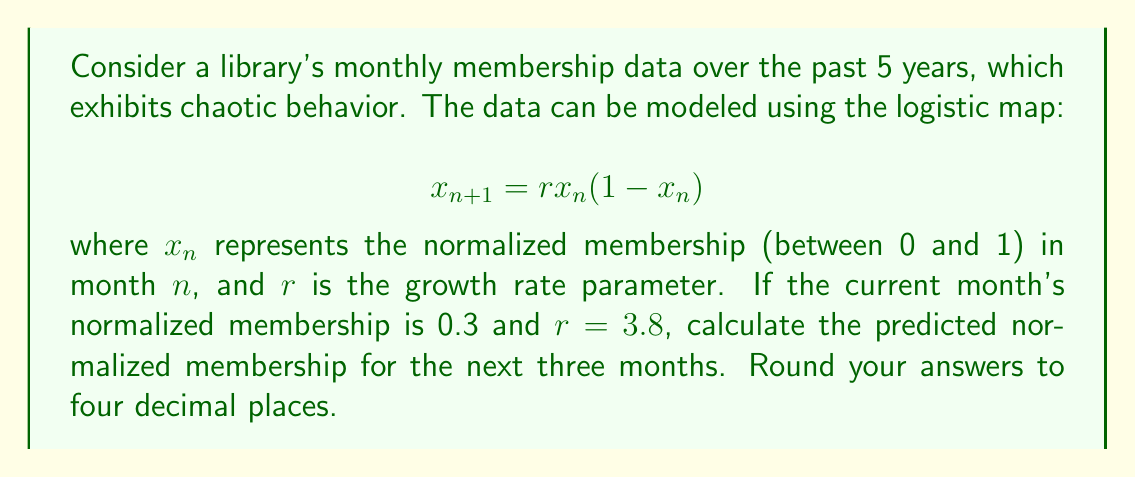Solve this math problem. To solve this problem, we'll use the logistic map equation iteratively for three months:

1. Given: $x_0 = 0.3$ and $r = 3.8$

2. For the first month ($n = 1$):
   $$x_1 = r \cdot x_0 \cdot (1-x_0)$$
   $$x_1 = 3.8 \cdot 0.3 \cdot (1-0.3)$$
   $$x_1 = 3.8 \cdot 0.3 \cdot 0.7$$
   $$x_1 = 0.798$$

3. For the second month ($n = 2$):
   $$x_2 = r \cdot x_1 \cdot (1-x_1)$$
   $$x_2 = 3.8 \cdot 0.798 \cdot (1-0.798)$$
   $$x_2 = 3.8 \cdot 0.798 \cdot 0.202$$
   $$x_2 = 0.6124$$

4. For the third month ($n = 3$):
   $$x_3 = r \cdot x_2 \cdot (1-x_2)$$
   $$x_3 = 3.8 \cdot 0.6124 \cdot (1-0.6124)$$
   $$x_3 = 3.8 \cdot 0.6124 \cdot 0.3876$$
   $$x_3 = 0.9023$$

5. Rounding all results to four decimal places:
   $x_1 = 0.7980$
   $x_2 = 0.6124$
   $x_3 = 0.9023$
Answer: 0.7980, 0.6124, 0.9023 